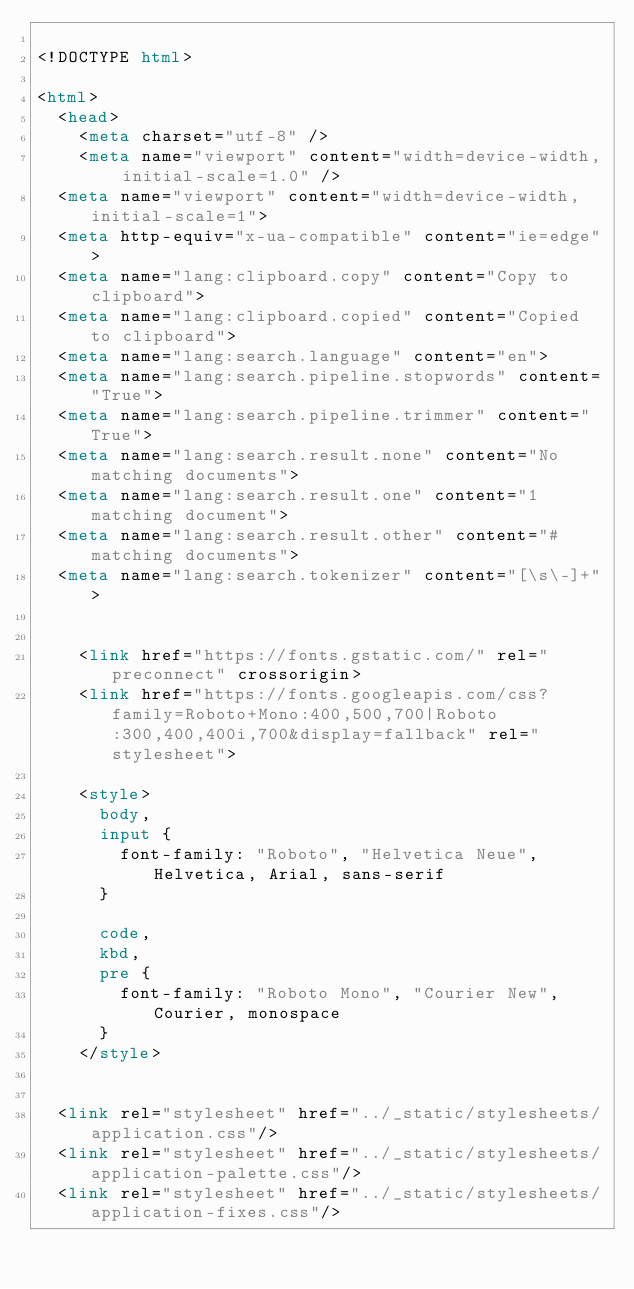Convert code to text. <code><loc_0><loc_0><loc_500><loc_500><_HTML_>
<!DOCTYPE html>

<html>
  <head>
    <meta charset="utf-8" />
    <meta name="viewport" content="width=device-width, initial-scale=1.0" />
  <meta name="viewport" content="width=device-width,initial-scale=1">
  <meta http-equiv="x-ua-compatible" content="ie=edge">
  <meta name="lang:clipboard.copy" content="Copy to clipboard">
  <meta name="lang:clipboard.copied" content="Copied to clipboard">
  <meta name="lang:search.language" content="en">
  <meta name="lang:search.pipeline.stopwords" content="True">
  <meta name="lang:search.pipeline.trimmer" content="True">
  <meta name="lang:search.result.none" content="No matching documents">
  <meta name="lang:search.result.one" content="1 matching document">
  <meta name="lang:search.result.other" content="# matching documents">
  <meta name="lang:search.tokenizer" content="[\s\-]+">

  
    <link href="https://fonts.gstatic.com/" rel="preconnect" crossorigin>
    <link href="https://fonts.googleapis.com/css?family=Roboto+Mono:400,500,700|Roboto:300,400,400i,700&display=fallback" rel="stylesheet">

    <style>
      body,
      input {
        font-family: "Roboto", "Helvetica Neue", Helvetica, Arial, sans-serif
      }

      code,
      kbd,
      pre {
        font-family: "Roboto Mono", "Courier New", Courier, monospace
      }
    </style>
  

  <link rel="stylesheet" href="../_static/stylesheets/application.css"/>
  <link rel="stylesheet" href="../_static/stylesheets/application-palette.css"/>
  <link rel="stylesheet" href="../_static/stylesheets/application-fixes.css"/>
  </code> 